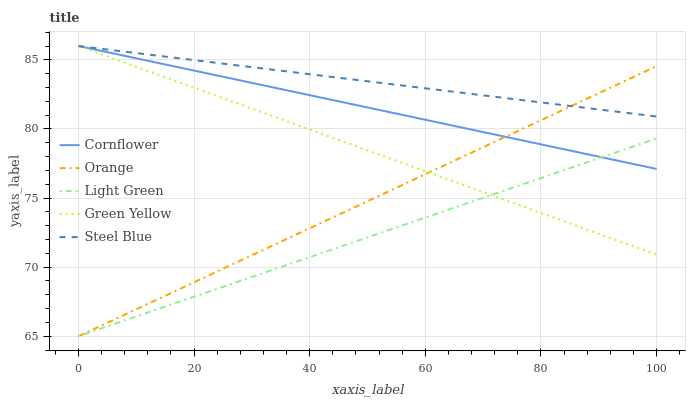Does Light Green have the minimum area under the curve?
Answer yes or no. Yes. Does Steel Blue have the maximum area under the curve?
Answer yes or no. Yes. Does Cornflower have the minimum area under the curve?
Answer yes or no. No. Does Cornflower have the maximum area under the curve?
Answer yes or no. No. Is Green Yellow the smoothest?
Answer yes or no. Yes. Is Light Green the roughest?
Answer yes or no. Yes. Is Cornflower the smoothest?
Answer yes or no. No. Is Cornflower the roughest?
Answer yes or no. No. Does Orange have the lowest value?
Answer yes or no. Yes. Does Cornflower have the lowest value?
Answer yes or no. No. Does Steel Blue have the highest value?
Answer yes or no. Yes. Does Light Green have the highest value?
Answer yes or no. No. Is Light Green less than Steel Blue?
Answer yes or no. Yes. Is Steel Blue greater than Light Green?
Answer yes or no. Yes. Does Orange intersect Cornflower?
Answer yes or no. Yes. Is Orange less than Cornflower?
Answer yes or no. No. Is Orange greater than Cornflower?
Answer yes or no. No. Does Light Green intersect Steel Blue?
Answer yes or no. No. 